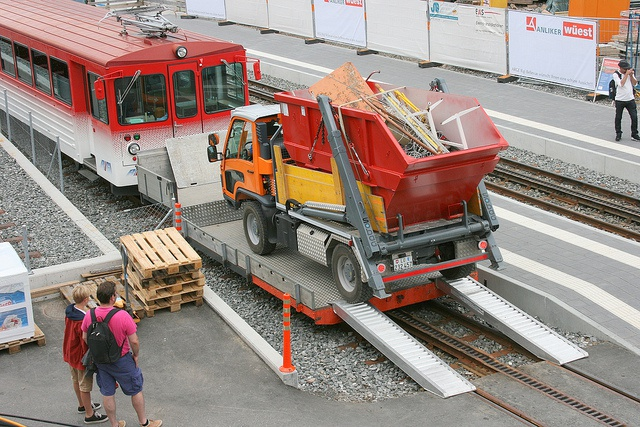Describe the objects in this image and their specific colors. I can see truck in pink, gray, brown, black, and darkgray tones, train in pink, black, lightgray, and darkgray tones, people in pink, black, and gray tones, people in pink, maroon, gray, and black tones, and people in pink, black, lightgray, darkgray, and gray tones in this image. 